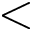Convert formula to latex. <formula><loc_0><loc_0><loc_500><loc_500><</formula> 